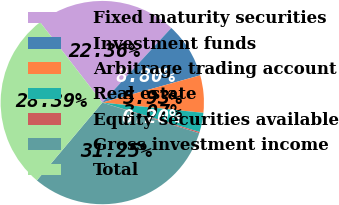Convert chart to OTSL. <chart><loc_0><loc_0><loc_500><loc_500><pie_chart><fcel>Fixed maturity securities<fcel>Investment funds<fcel>Arbitrage trading account<fcel>Real estate<fcel>Equity securities available<fcel>Gross investment income<fcel>Total<nl><fcel>22.36%<fcel>8.8%<fcel>5.93%<fcel>3.07%<fcel>0.2%<fcel>31.25%<fcel>28.39%<nl></chart> 